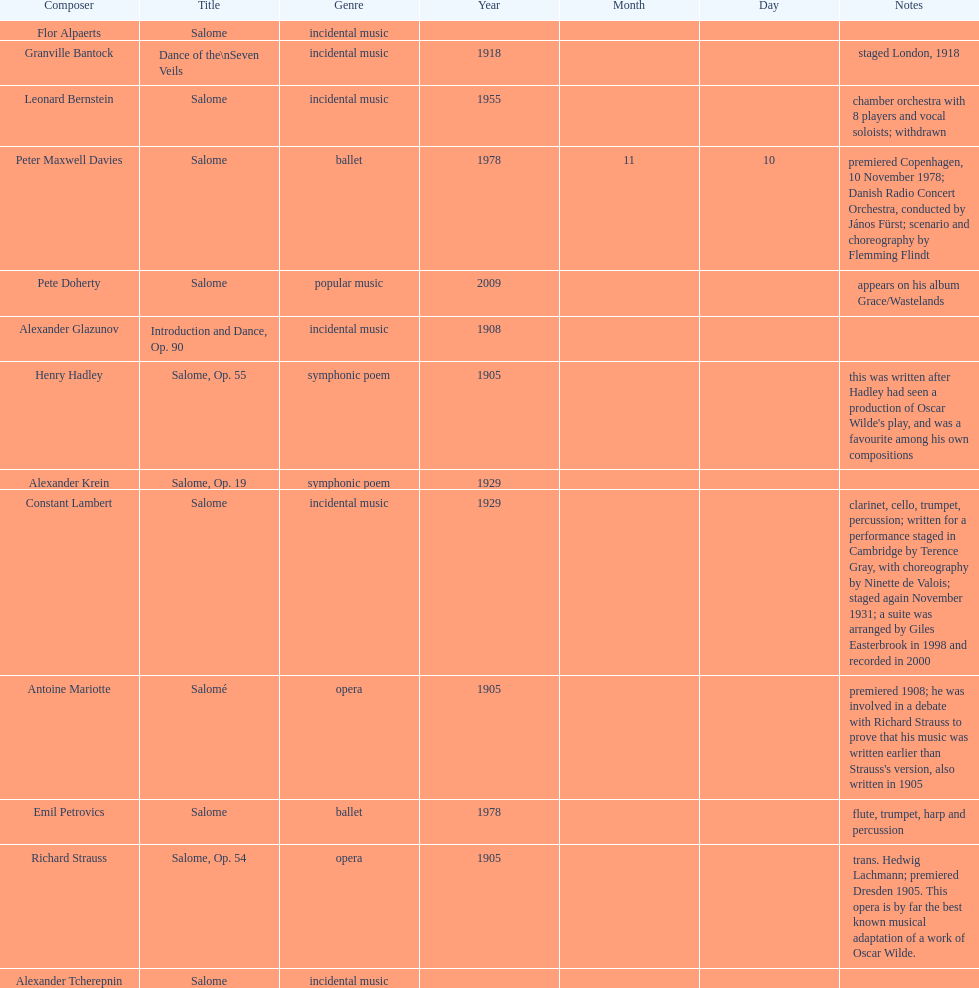Which composer published first granville bantock or emil petrovics? Granville Bantock. 